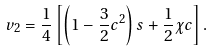Convert formula to latex. <formula><loc_0><loc_0><loc_500><loc_500>v _ { 2 } = \frac { 1 } { 4 } \left [ \left ( 1 - \frac { 3 } { 2 } c ^ { 2 } \right ) s + \frac { 1 } { 2 } \chi c \right ] .</formula> 